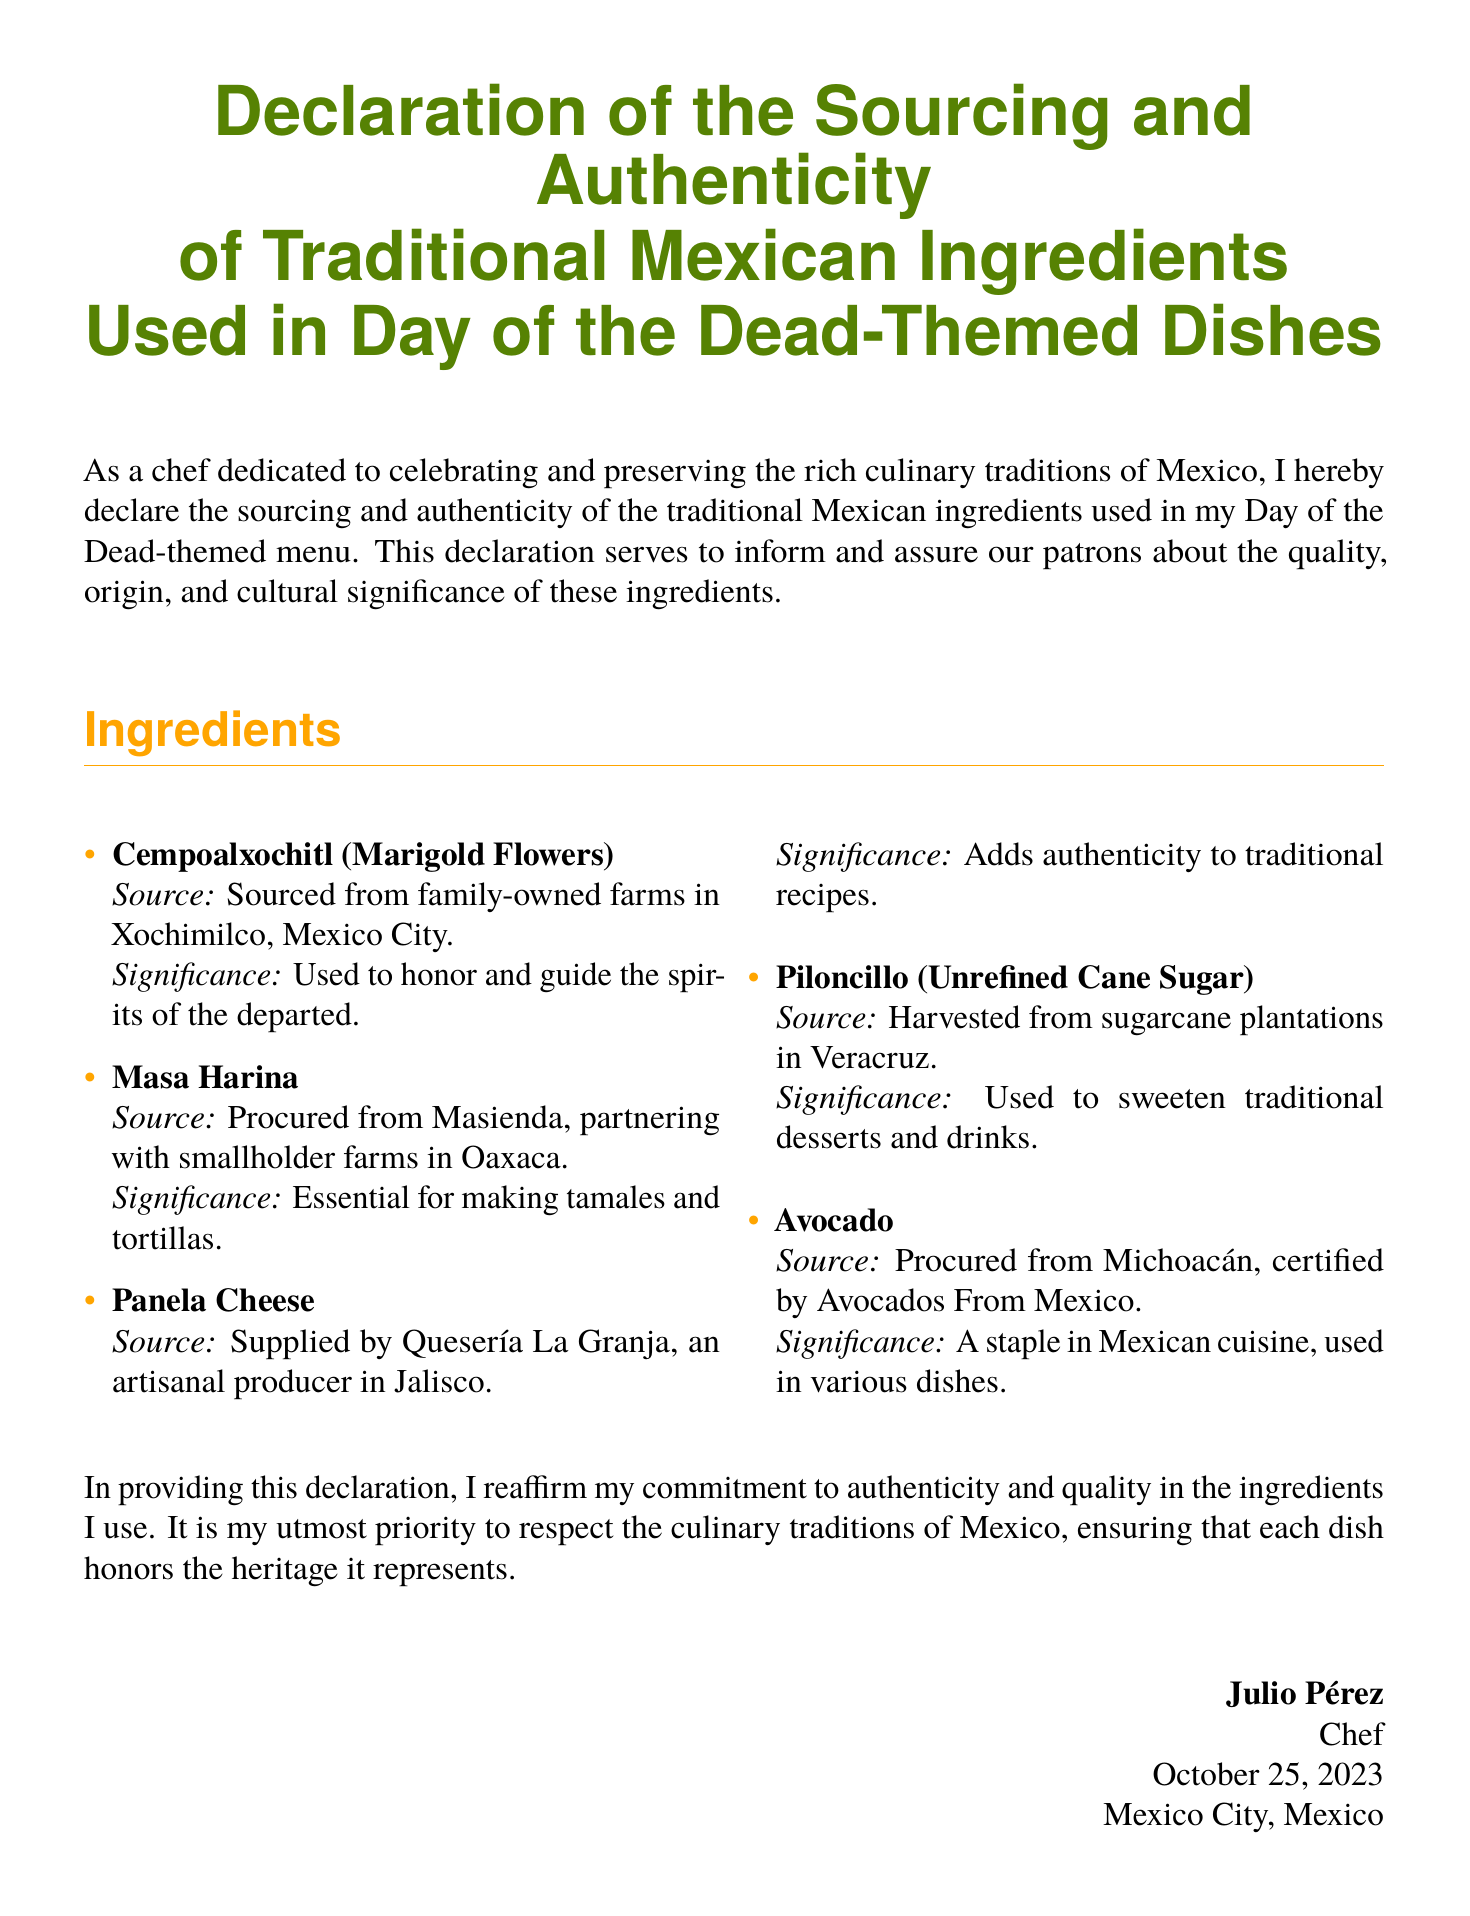What is the document about? The document is a declaration regarding the sourcing and authenticity of traditional Mexican ingredients used in Day of the Dead-themed dishes.
Answer: Declaration of the Sourcing and Authenticity Who is the chef signing the document? The chef who signs the document is identified at the end, providing their name and title.
Answer: Julio Pérez When was the declaration signed? The date of signing is indicated towards the end of the document.
Answer: October 25, 2023 Which ingredient is sourced from Oaxaca? The document lists various ingredients along with their sources, including this specific ingredient.
Answer: Masa Harina What is the significance of Cempoalxochitl? Each ingredient includes a section describing its cultural significance, specifically for this flower.
Answer: Used to honor and guide the spirits of the departed Which region is mentioned for sourcing Avocado? The avocado’s source is explicitly stated in the ingredient list.
Answer: Michoacán What type of sugar is Piloncillo? The document provides a specific type of sugar used in traditional recipes.
Answer: Unrefined Cane Sugar What is the source of Panela Cheese? The provenance of each ingredient is mentioned; this one has a specific supplier.
Answer: Quesería La Granja What kind of farms are Cempoalxochitl sourced from? The document describes the types of farms contributing to the ingredient sourcing.
Answer: Family-owned farms 